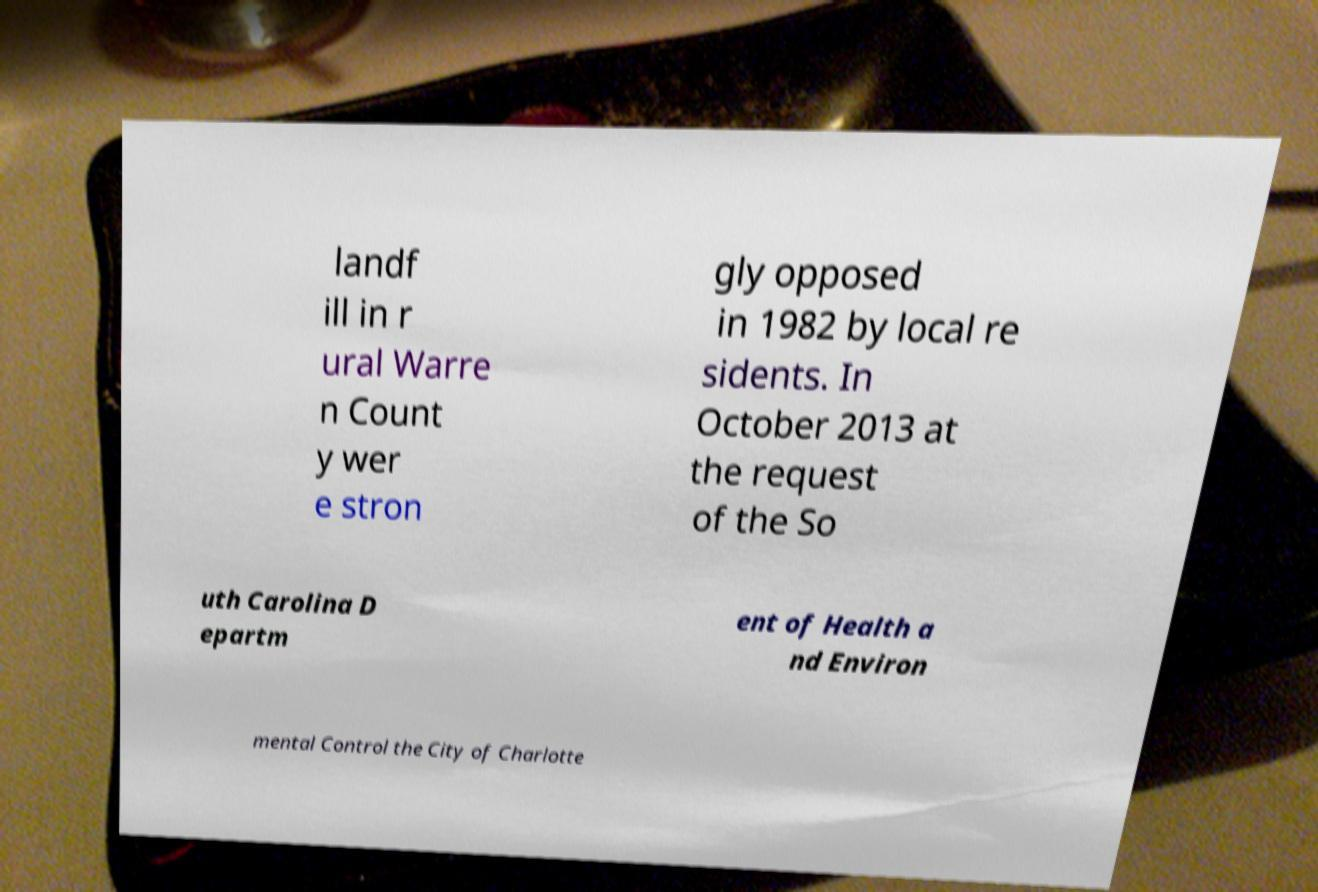Can you read and provide the text displayed in the image?This photo seems to have some interesting text. Can you extract and type it out for me? landf ill in r ural Warre n Count y wer e stron gly opposed in 1982 by local re sidents. In October 2013 at the request of the So uth Carolina D epartm ent of Health a nd Environ mental Control the City of Charlotte 